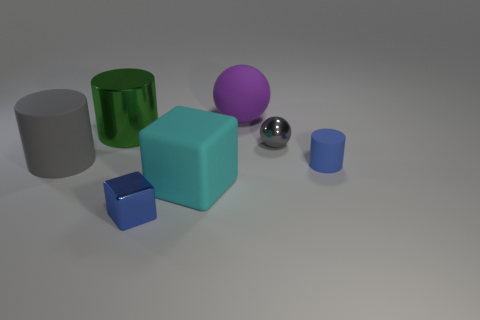Compare the lighting in the image. Is it consistent across all objects? The lighting in the image appears to be uniform, casting soft shadows directly beneath each object, which suggests a diffuse, overhead light source. 